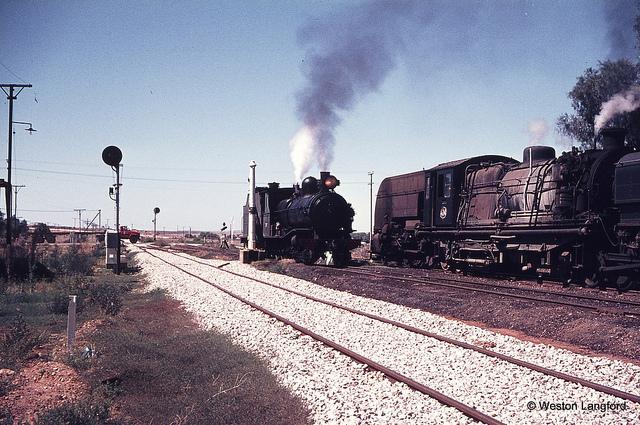What type of locomotive is this?
Quick response, please. Steam. Are those electric trains?
Concise answer only. No. What are the plumes coming from the top ooh the train?
Keep it brief. Smoke. 